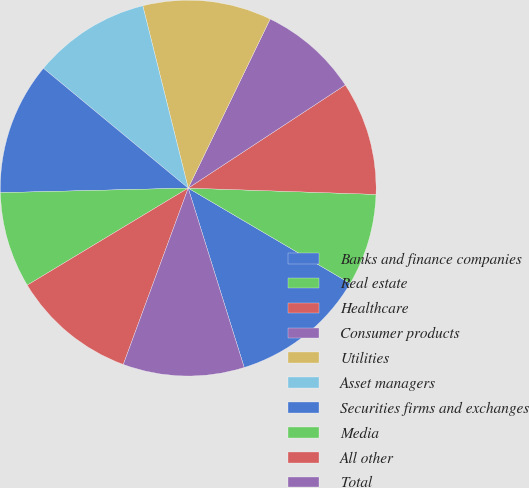<chart> <loc_0><loc_0><loc_500><loc_500><pie_chart><fcel>Banks and finance companies<fcel>Real estate<fcel>Healthcare<fcel>Consumer products<fcel>Utilities<fcel>Asset managers<fcel>Securities firms and exchanges<fcel>Media<fcel>All other<fcel>Total<nl><fcel>11.72%<fcel>7.93%<fcel>9.78%<fcel>8.57%<fcel>11.07%<fcel>10.11%<fcel>11.39%<fcel>8.25%<fcel>10.75%<fcel>10.43%<nl></chart> 